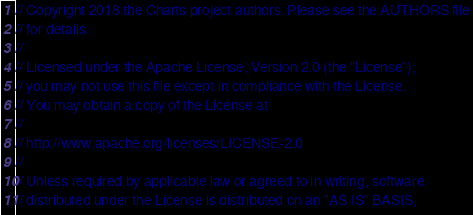Convert code to text. <code><loc_0><loc_0><loc_500><loc_500><_Dart_>// Copyright 2018 the Charts project authors. Please see the AUTHORS file
// for details.
//
// Licensed under the Apache License, Version 2.0 (the "License");
// you may not use this file except in compliance with the License.
// You may obtain a copy of the License at
//
// http://www.apache.org/licenses/LICENSE-2.0
//
// Unless required by applicable law or agreed to in writing, software
// distributed under the License is distributed on an "AS IS" BASIS,</code> 